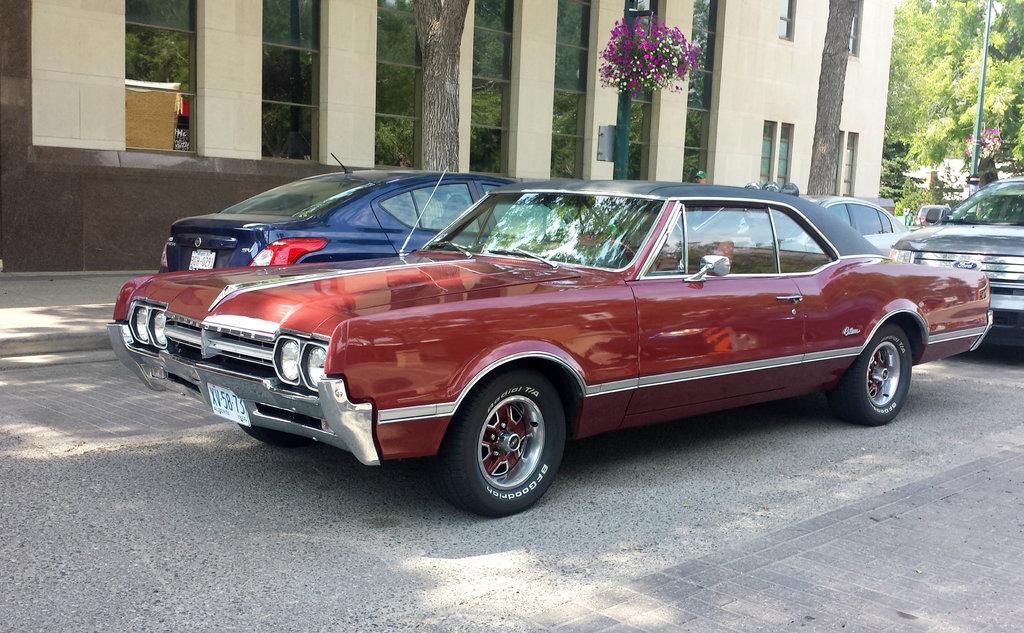Can you describe this image briefly? In this picture we can see many cars on the road. On the background there is a building. On the top right corner we can see sky, green color pole, tree and plants. 